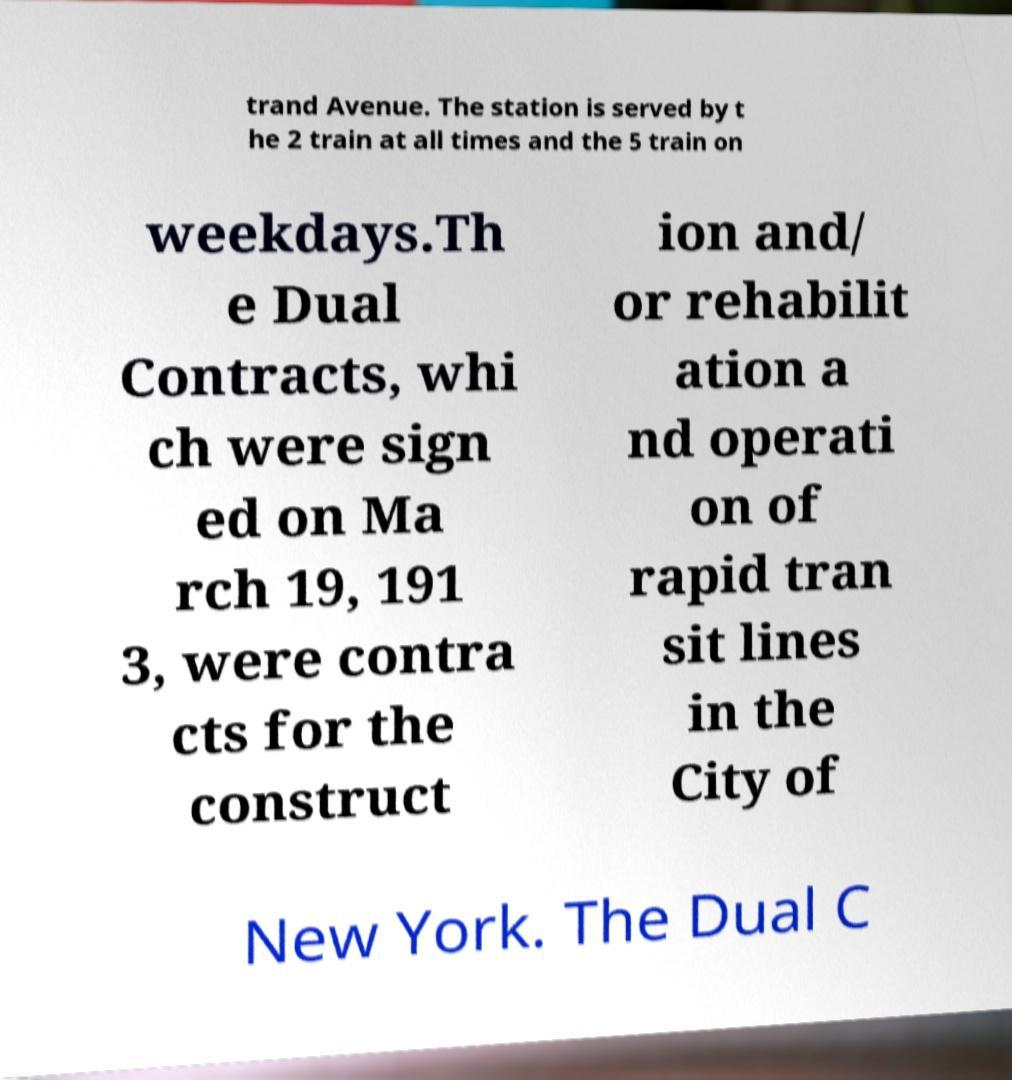I need the written content from this picture converted into text. Can you do that? trand Avenue. The station is served by t he 2 train at all times and the 5 train on weekdays.Th e Dual Contracts, whi ch were sign ed on Ma rch 19, 191 3, were contra cts for the construct ion and/ or rehabilit ation a nd operati on of rapid tran sit lines in the City of New York. The Dual C 